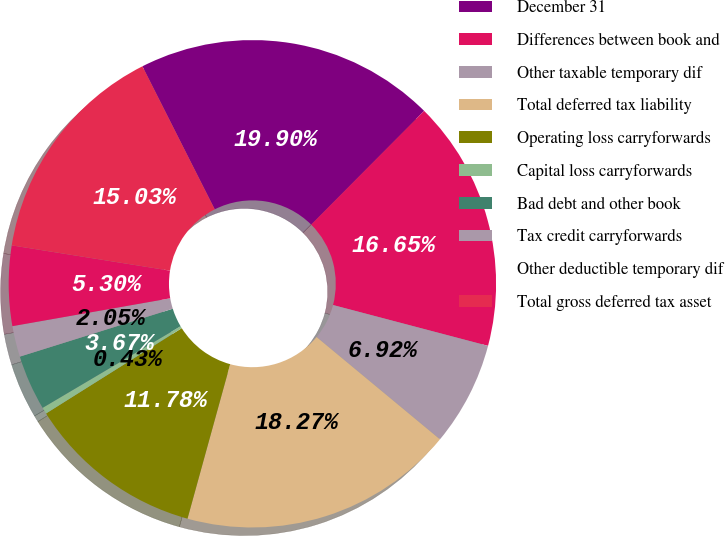<chart> <loc_0><loc_0><loc_500><loc_500><pie_chart><fcel>December 31<fcel>Differences between book and<fcel>Other taxable temporary dif<fcel>Total deferred tax liability<fcel>Operating loss carryforwards<fcel>Capital loss carryforwards<fcel>Bad debt and other book<fcel>Tax credit carryforwards<fcel>Other deductible temporary dif<fcel>Total gross deferred tax asset<nl><fcel>19.9%<fcel>16.65%<fcel>6.92%<fcel>18.27%<fcel>11.78%<fcel>0.43%<fcel>3.67%<fcel>2.05%<fcel>5.3%<fcel>15.03%<nl></chart> 